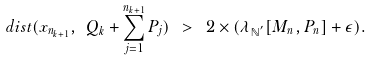Convert formula to latex. <formula><loc_0><loc_0><loc_500><loc_500>d i s t ( x _ { n _ { k + 1 } } , \ Q _ { k } + \sum _ { j = 1 } ^ { n _ { k + 1 } } P _ { j } ) \ > \ 2 \times ( \lambda _ { \mathbb { N } ^ { ^ { \prime } } } [ M _ { n } , P _ { n } ] + \epsilon ) .</formula> 